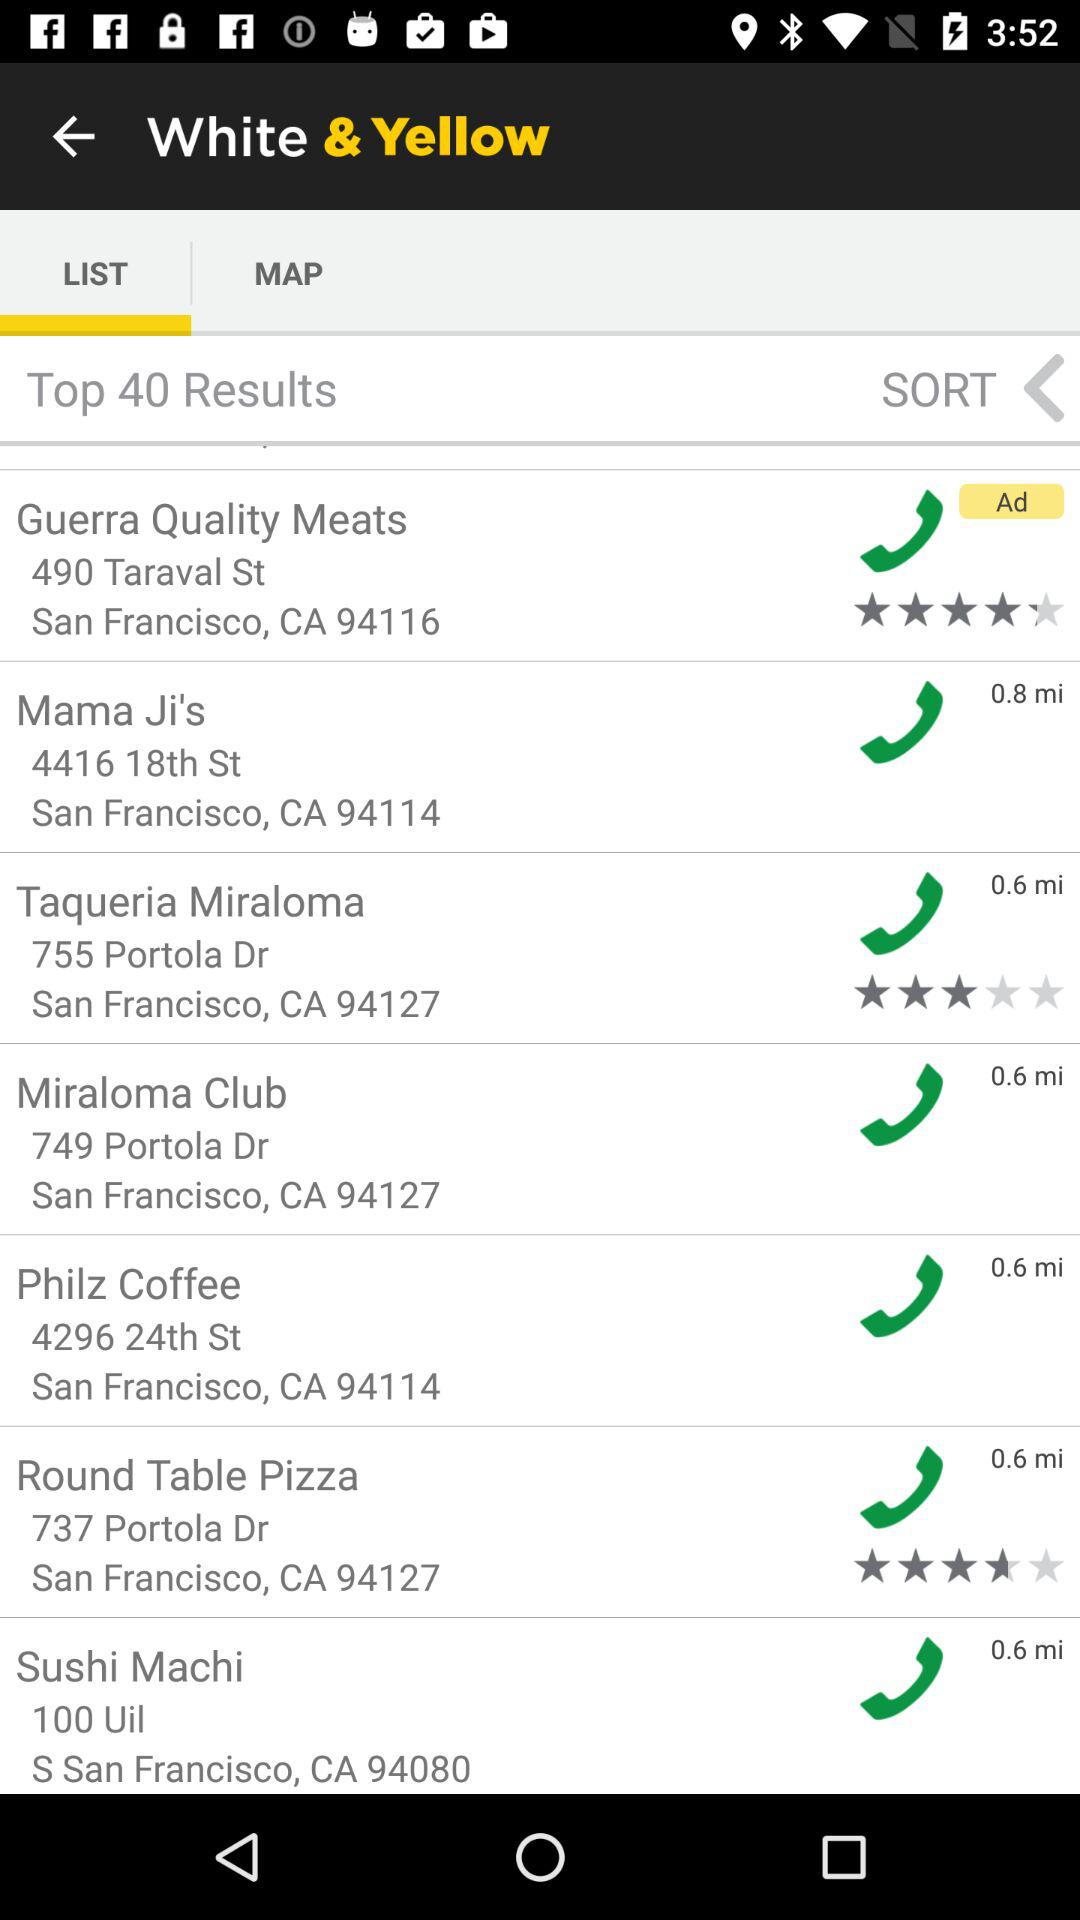What is the location of "Round Table Pizza"? The location of "Round Table Pizza" is San Francisco, CA 94127. 